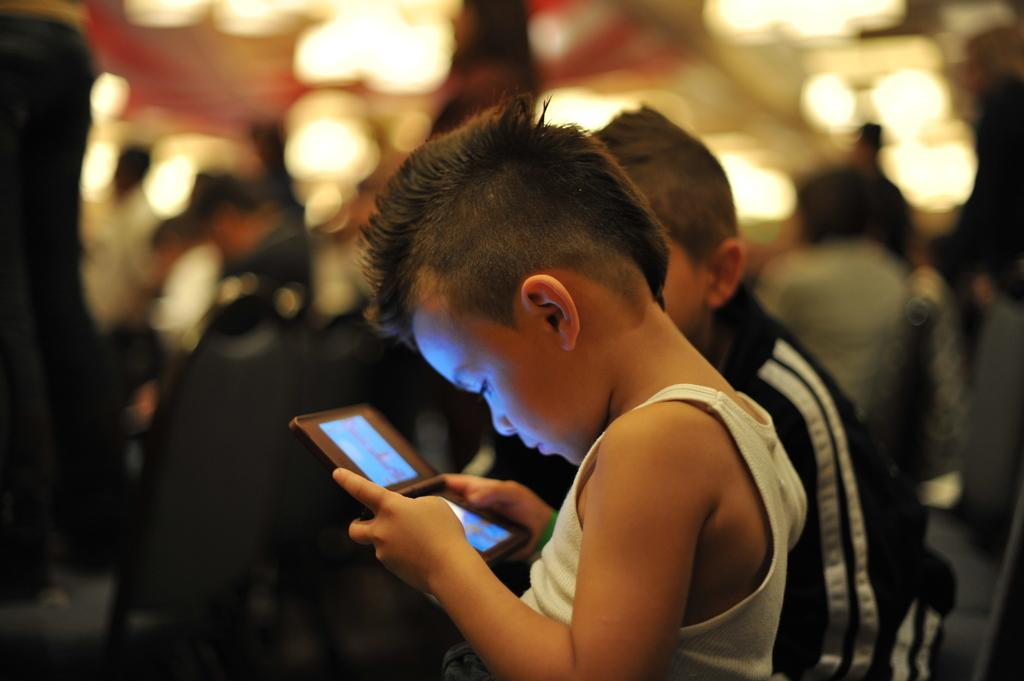What is the boy in the image doing? There is a boy playing on a tablet in the image. Can you describe the other boy in the image? There is another boy beside him. What can be seen in the background of the image? There are lights visible in the background of the image. How many people are in the background of the image? There are many people in the background of the image. What type of plate is the boy using to express his opinion in the image? There is no plate or expression of opinion present in the image. Can you describe the ant's behavior in the image? There are no ants present in the image. 